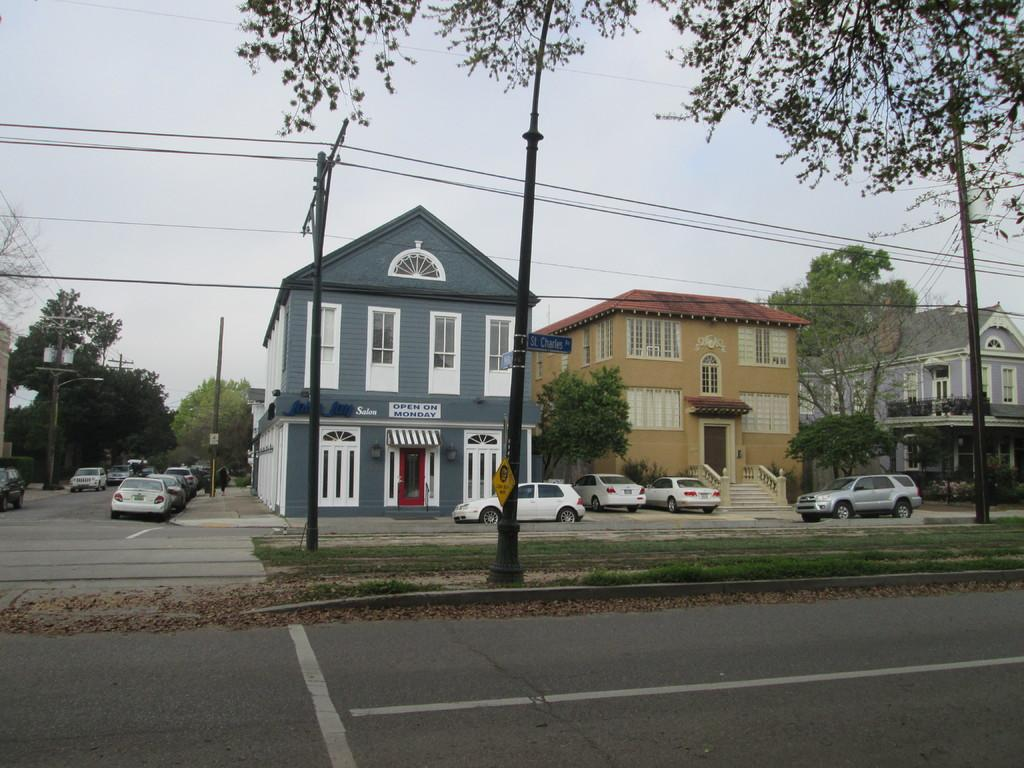What structures can be seen in the image? There are poles and sign boards in the image. What type of vehicles are present in the image? There are cars on the road in the image. What can be seen in the background of the image? There are trees and houses in the background of the image. What brand of toothpaste is advertised on the sign boards in the image? There is no toothpaste advertised on the sign boards in the image. How many beds can be seen in the image? There are no beds present in the image. 